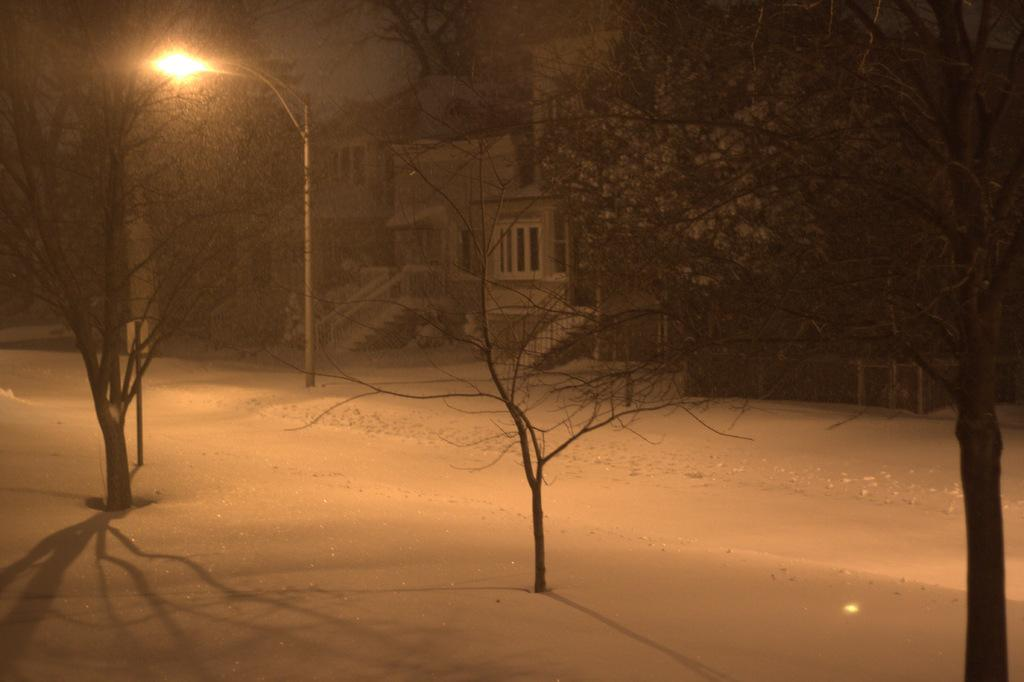What type of vegetation is visible in the image? There are trees in the image. What type of structures can be seen in the image? There are houses in the image. What is attached to the pole in the image? There is a light attached to the pole in the image. What type of architectural feature is present in the image? There are railings in the image. What is a possible way to move between different levels in the image? There are stairs in the image. What is the weather condition in the image? There is snow in the image. Can you tell me how many ducks are swimming in the snow in the image? There are no ducks present in the image; it features trees, houses, a pole with a light, railings, stairs, and snow. What type of vegetable is being used as a hat by the cabbage in the image? There is no cabbage present in the image, nor is there any indication of a vegetable being used as a hat. 